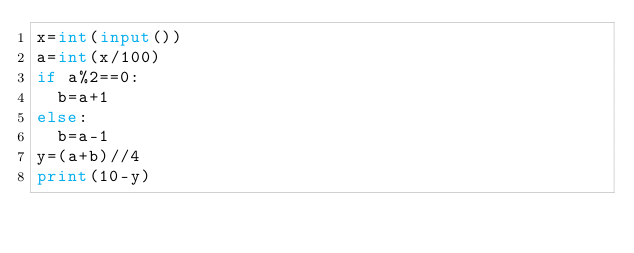<code> <loc_0><loc_0><loc_500><loc_500><_Python_>x=int(input())
a=int(x/100)
if a%2==0:
	b=a+1
else:
	b=a-1
y=(a+b)//4
print(10-y)</code> 